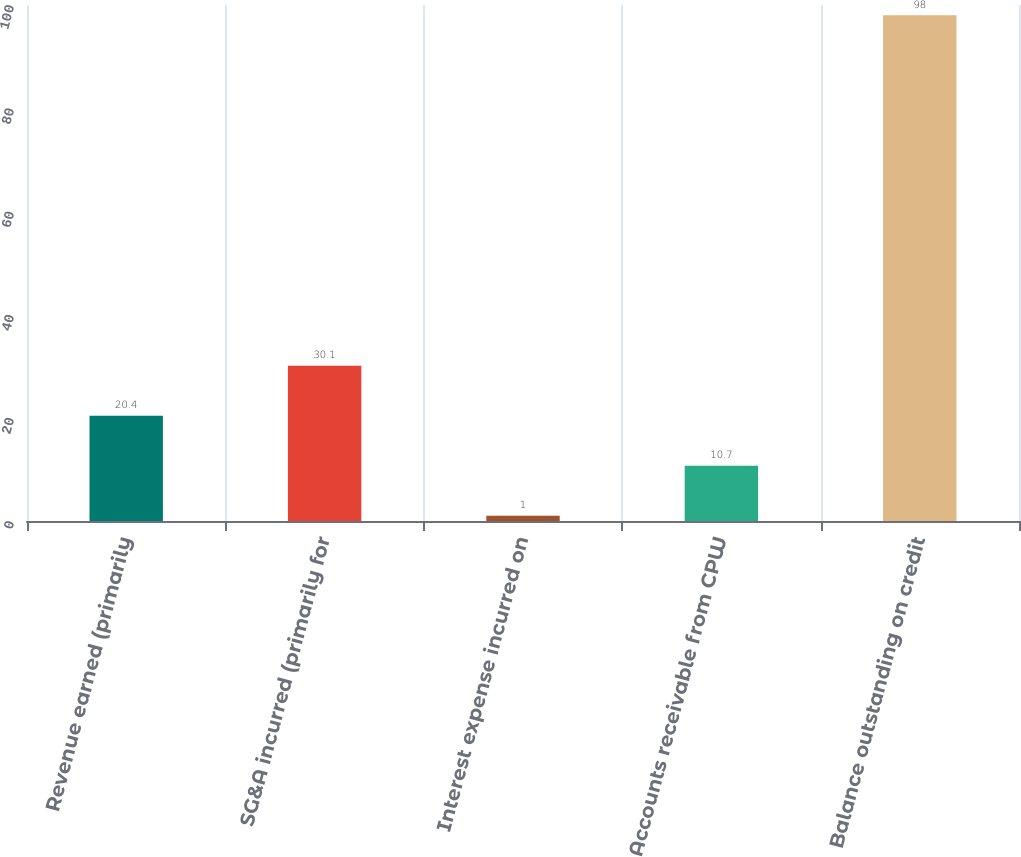Convert chart to OTSL. <chart><loc_0><loc_0><loc_500><loc_500><bar_chart><fcel>Revenue earned (primarily<fcel>SG&A incurred (primarily for<fcel>Interest expense incurred on<fcel>Accounts receivable from CPW<fcel>Balance outstanding on credit<nl><fcel>20.4<fcel>30.1<fcel>1<fcel>10.7<fcel>98<nl></chart> 